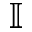<formula> <loc_0><loc_0><loc_500><loc_500>\mathbb { I }</formula> 